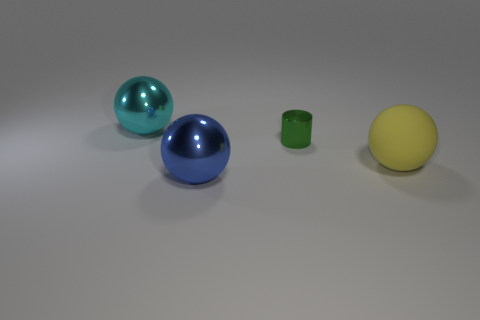Add 1 large cyan metal spheres. How many objects exist? 5 Subtract all balls. How many objects are left? 1 Subtract all small green blocks. Subtract all big cyan metallic spheres. How many objects are left? 3 Add 3 large yellow spheres. How many large yellow spheres are left? 4 Add 4 big yellow rubber balls. How many big yellow rubber balls exist? 5 Subtract 0 yellow blocks. How many objects are left? 4 